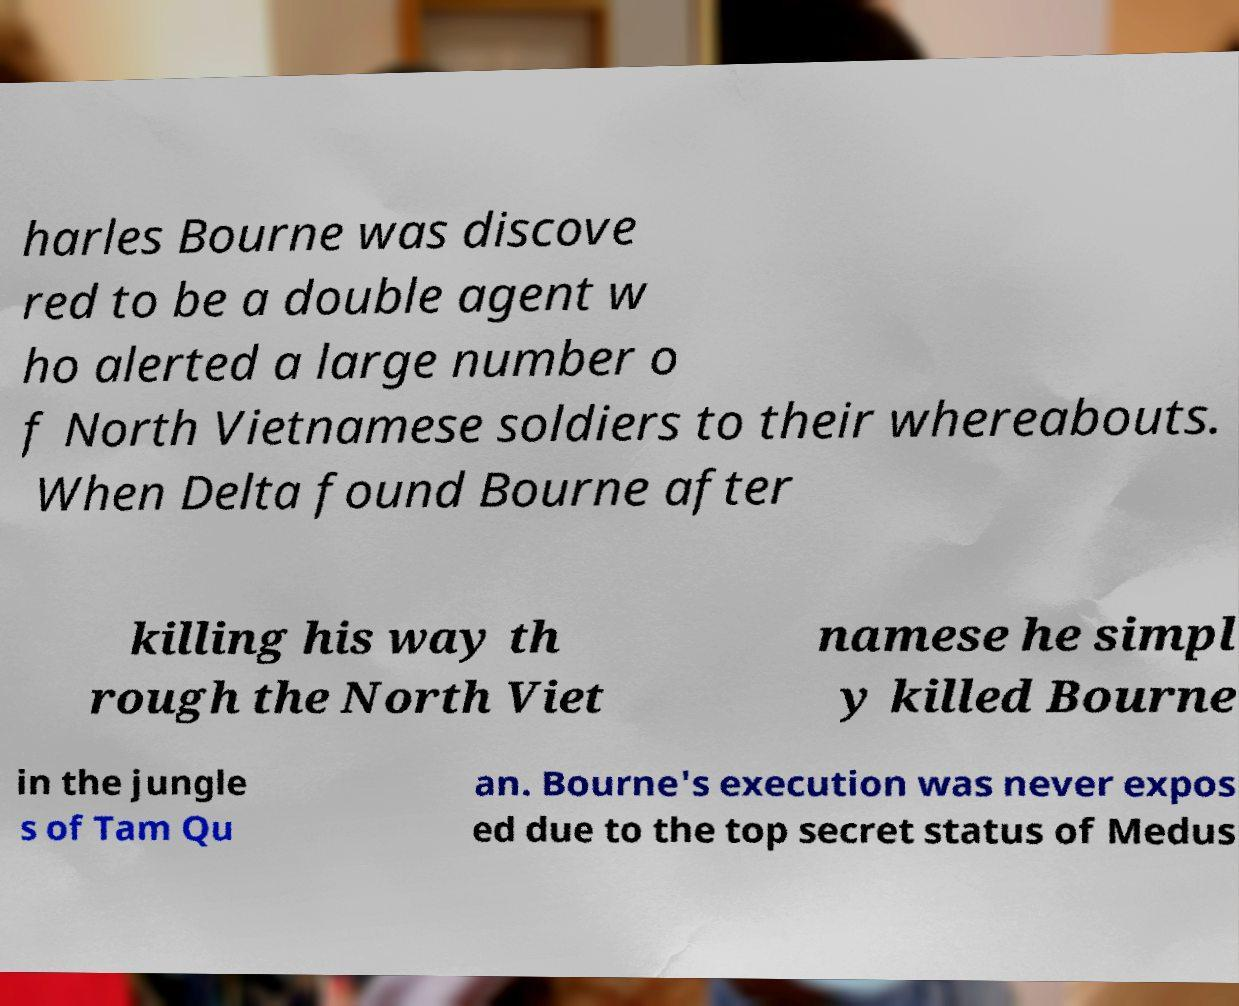For documentation purposes, I need the text within this image transcribed. Could you provide that? harles Bourne was discove red to be a double agent w ho alerted a large number o f North Vietnamese soldiers to their whereabouts. When Delta found Bourne after killing his way th rough the North Viet namese he simpl y killed Bourne in the jungle s of Tam Qu an. Bourne's execution was never expos ed due to the top secret status of Medus 